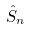Convert formula to latex. <formula><loc_0><loc_0><loc_500><loc_500>\hat { S } _ { n }</formula> 